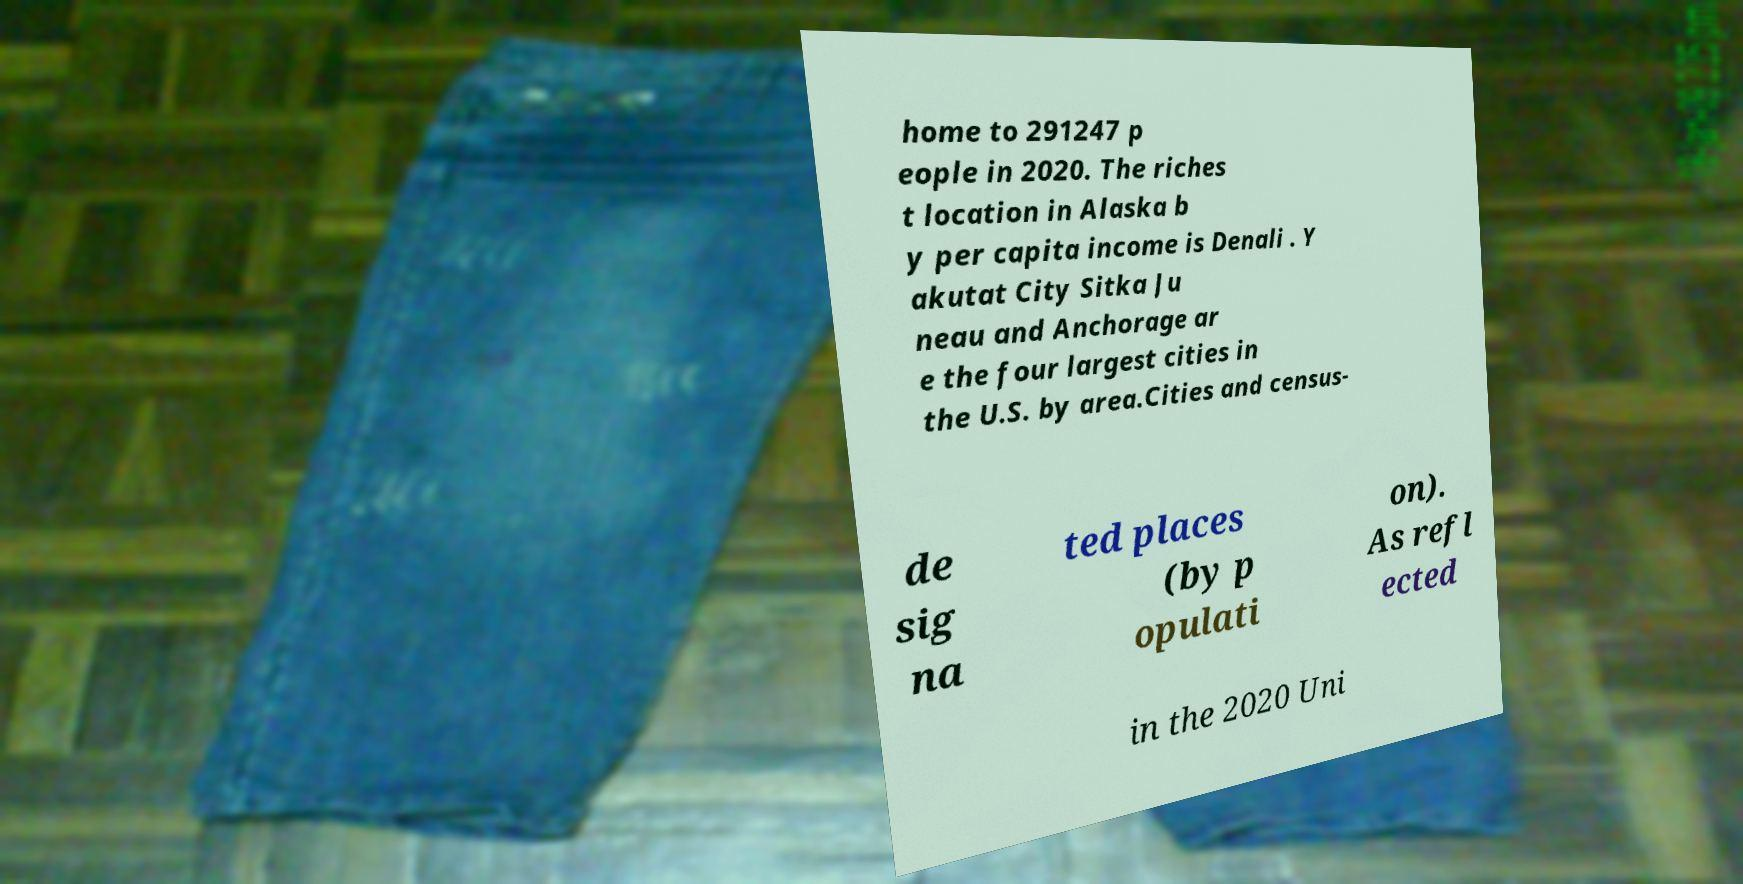Please identify and transcribe the text found in this image. home to 291247 p eople in 2020. The riches t location in Alaska b y per capita income is Denali . Y akutat City Sitka Ju neau and Anchorage ar e the four largest cities in the U.S. by area.Cities and census- de sig na ted places (by p opulati on). As refl ected in the 2020 Uni 